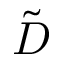Convert formula to latex. <formula><loc_0><loc_0><loc_500><loc_500>\tilde { D }</formula> 